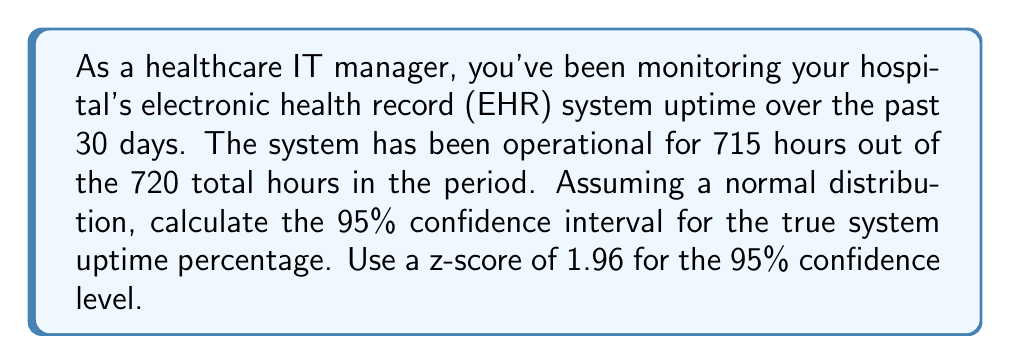Can you answer this question? Let's approach this step-by-step:

1) First, calculate the sample uptime percentage:
   $$p = \frac{715}{720} = 0.9931 = 99.31\%$$

2) The sample size (n) is the total number of hours: 720

3) For a confidence interval of a proportion, we use the formula:
   $$CI = p \pm z\sqrt{\frac{p(1-p)}{n}}$$

   Where:
   - p is the sample proportion
   - z is the z-score (1.96 for 95% confidence)
   - n is the sample size

4) Calculate the standard error:
   $$SE = \sqrt{\frac{p(1-p)}{n}} = \sqrt{\frac{0.9931(1-0.9931)}{720}} = 0.00305$$

5) Calculate the margin of error:
   $$ME = z \times SE = 1.96 \times 0.00305 = 0.00598$$

6) Calculate the confidence interval:
   Lower bound: $$99.31\% - 0.598\% = 98.71\%$$
   Upper bound: $$99.31\% + 0.598\% = 99.91\%$$

Therefore, we can say with 95% confidence that the true system uptime percentage falls between 98.71% and 99.91%.
Answer: (98.71%, 99.91%) 